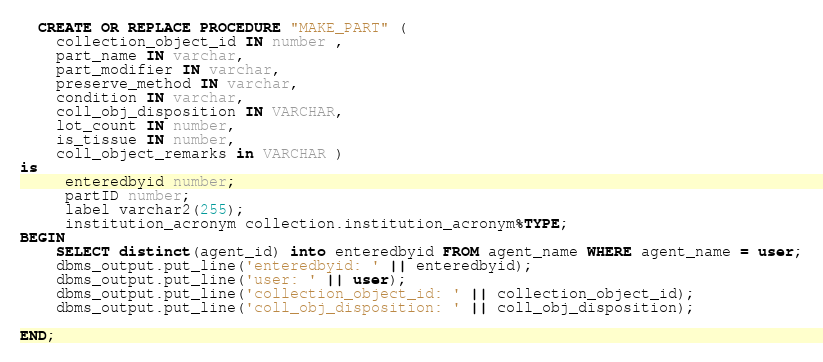<code> <loc_0><loc_0><loc_500><loc_500><_SQL_>
  CREATE OR REPLACE PROCEDURE "MAKE_PART" (
	collection_object_id IN number ,
	part_name IN varchar,
	part_modifier IN varchar,
	preserve_method IN varchar,
	condition IN varchar,
	coll_obj_disposition IN VARCHAR,
	lot_count IN number,
	is_tissue IN number,
	coll_object_remarks in VARCHAR )
is
	 enteredbyid number;
	 partID number;
	 label varchar2(255);
	 institution_acronym collection.institution_acronym%TYPE;
BEGIN
	SELECT distinct(agent_id) into enteredbyid FROM agent_name WHERE agent_name = user;
	dbms_output.put_line('enteredbyid: ' || enteredbyid);
	dbms_output.put_line('user: ' || user);
	dbms_output.put_line('collection_object_id: ' || collection_object_id);
	dbms_output.put_line('coll_obj_disposition: ' || coll_obj_disposition);

END;</code> 